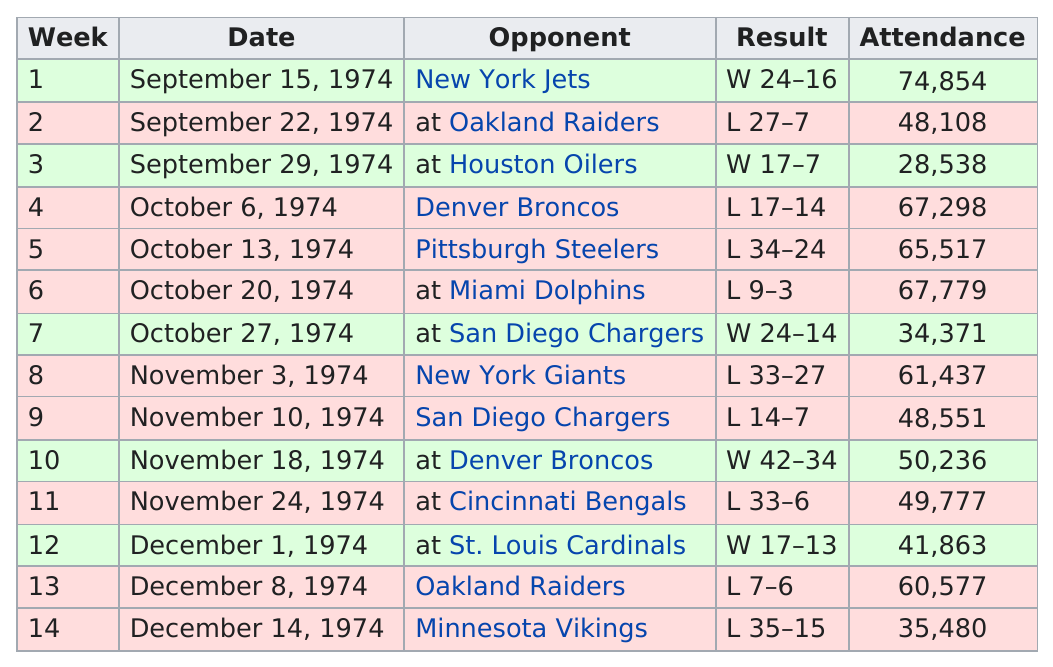Point out several critical features in this image. November or December had more games? November. During that season, a total of three opponents were played twice, indicating a strong focus on competition and improvement. On October 6, 1974, they played the Broncos and unfortunately lost the game. In 1974, the Chiefs and Broncos played each other a total of two times. The next largest attendance record after 74,854 is 67,779. 